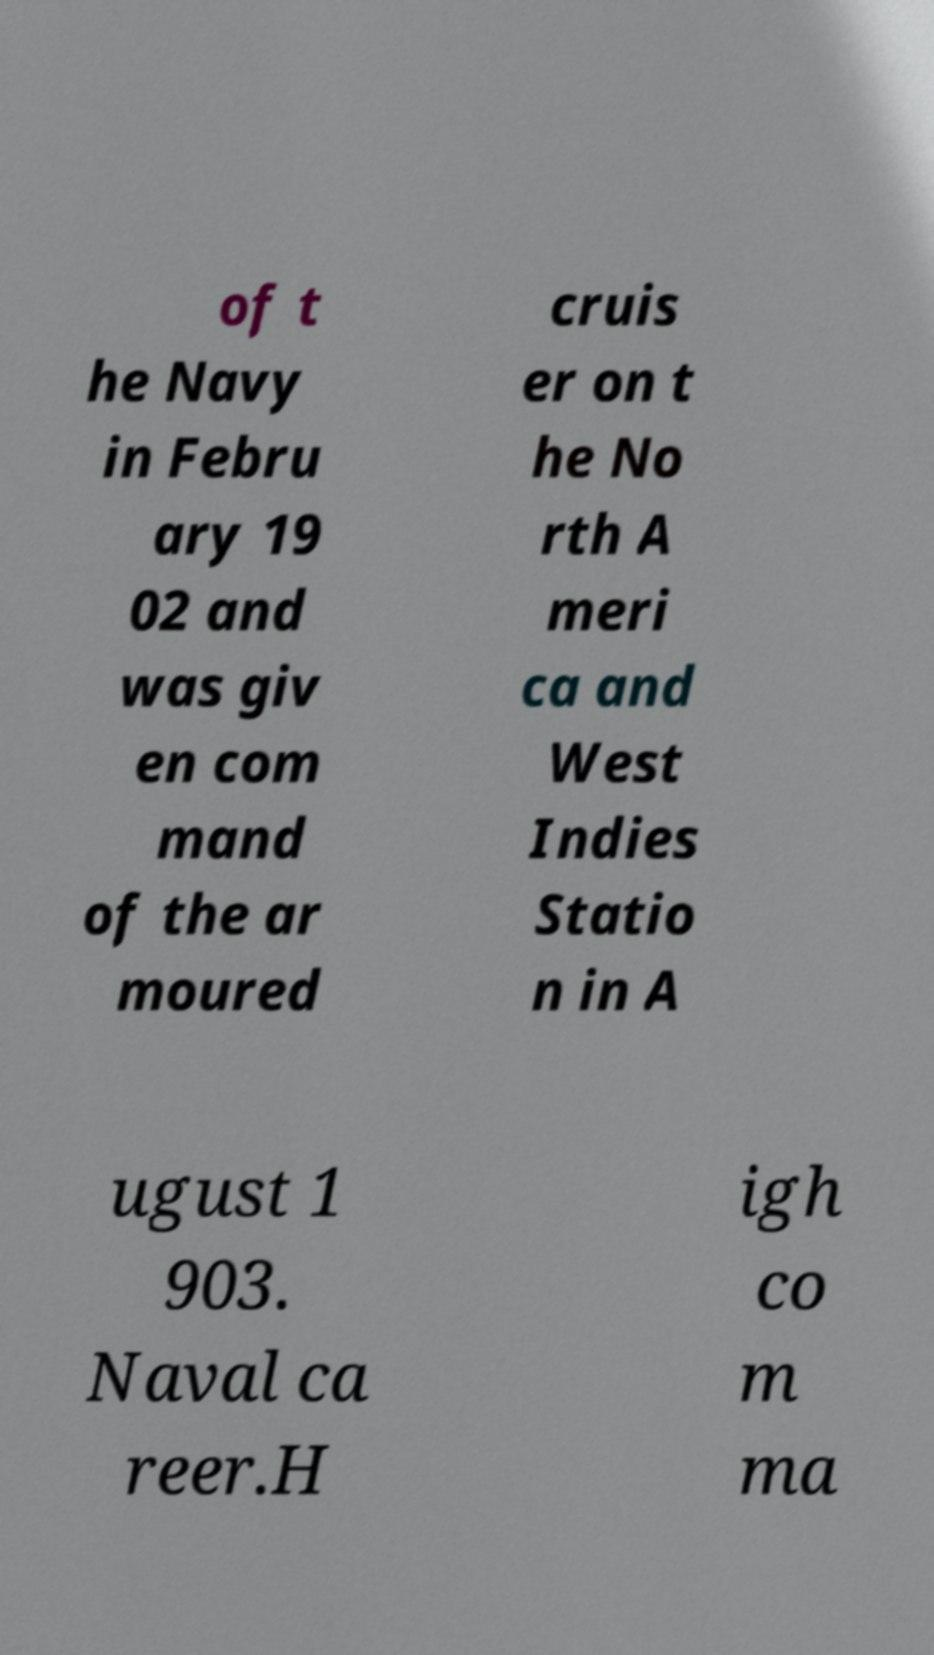I need the written content from this picture converted into text. Can you do that? of t he Navy in Febru ary 19 02 and was giv en com mand of the ar moured cruis er on t he No rth A meri ca and West Indies Statio n in A ugust 1 903. Naval ca reer.H igh co m ma 